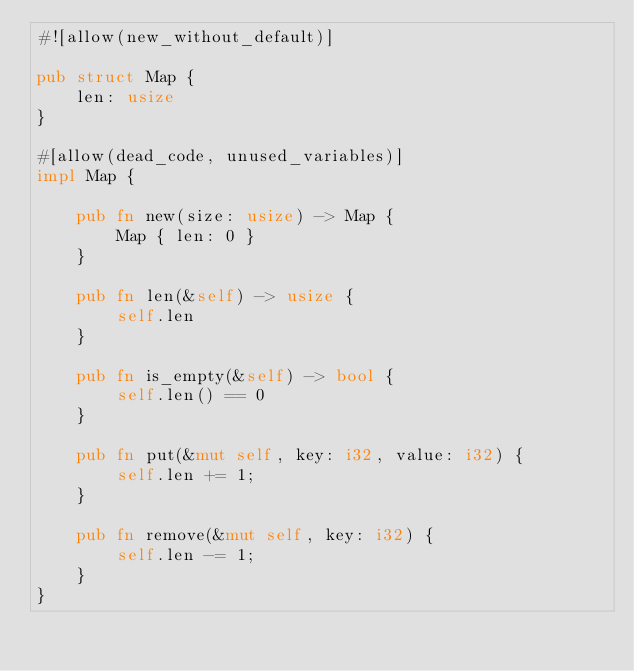<code> <loc_0><loc_0><loc_500><loc_500><_Rust_>#![allow(new_without_default)]

pub struct Map {
    len: usize
}

#[allow(dead_code, unused_variables)]
impl Map {

    pub fn new(size: usize) -> Map {
        Map { len: 0 }
    }

    pub fn len(&self) -> usize {
        self.len
    }

    pub fn is_empty(&self) -> bool {
        self.len() == 0
    }

    pub fn put(&mut self, key: i32, value: i32) {
        self.len += 1;
    }

    pub fn remove(&mut self, key: i32) {
        self.len -= 1;
    }
}
</code> 